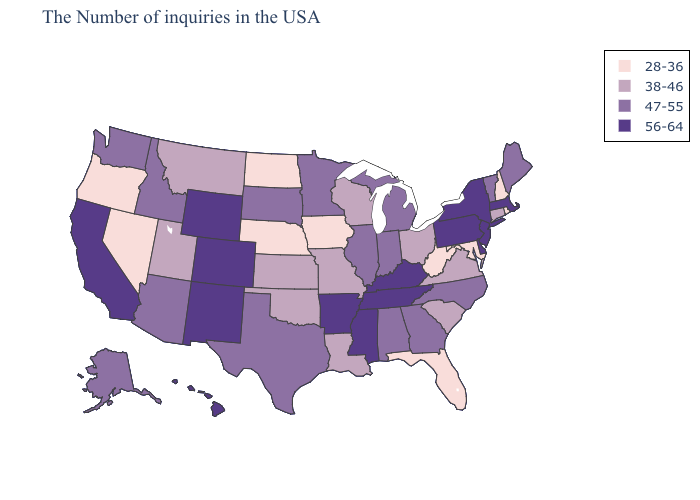Does Hawaii have the same value as Mississippi?
Concise answer only. Yes. How many symbols are there in the legend?
Short answer required. 4. Among the states that border Missouri , does Kansas have the highest value?
Concise answer only. No. What is the lowest value in the USA?
Quick response, please. 28-36. What is the lowest value in the Northeast?
Write a very short answer. 28-36. Does the map have missing data?
Answer briefly. No. Among the states that border Oregon , which have the lowest value?
Short answer required. Nevada. Does the first symbol in the legend represent the smallest category?
Short answer required. Yes. What is the value of Pennsylvania?
Concise answer only. 56-64. Which states have the lowest value in the West?
Give a very brief answer. Nevada, Oregon. Name the states that have a value in the range 28-36?
Write a very short answer. Rhode Island, New Hampshire, Maryland, West Virginia, Florida, Iowa, Nebraska, North Dakota, Nevada, Oregon. Which states have the lowest value in the USA?
Short answer required. Rhode Island, New Hampshire, Maryland, West Virginia, Florida, Iowa, Nebraska, North Dakota, Nevada, Oregon. What is the value of California?
Concise answer only. 56-64. What is the value of New York?
Write a very short answer. 56-64. Which states have the lowest value in the Northeast?
Short answer required. Rhode Island, New Hampshire. 